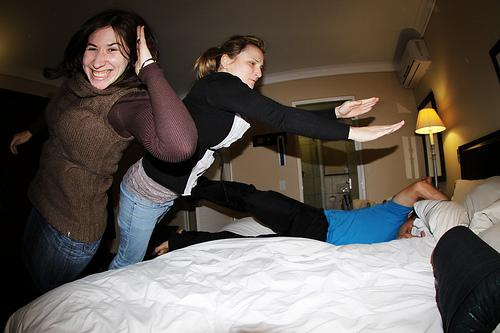Question: how many hands are visible?
Choices:
A. Four.
B. One.
C. Two.
D. Three.
Answer with the letter. Answer: A Question: where was this photo taken?
Choices:
A. Cruise ship.
B. A hotel.
C. Police station.
D. At the dry river bed.
Answer with the letter. Answer: B Question: why are these people in mid air?
Choices:
A. Sky diving.
B. They are jumping.
C. Diving off a cliff.
D. Trying to catch a bouquet of flowers.
Answer with the letter. Answer: B 